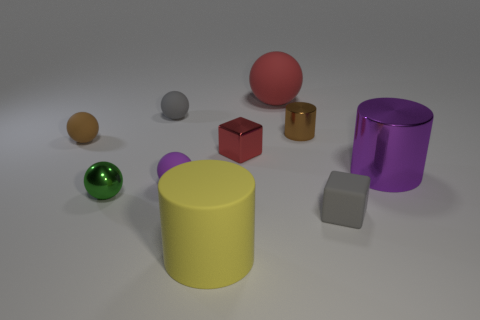Subtract 2 spheres. How many spheres are left? 3 Subtract all purple balls. How many balls are left? 4 Subtract all tiny brown rubber spheres. How many spheres are left? 4 Subtract all yellow balls. Subtract all brown blocks. How many balls are left? 5 Subtract all cubes. How many objects are left? 8 Add 9 tiny metallic blocks. How many tiny metallic blocks are left? 10 Add 8 yellow cylinders. How many yellow cylinders exist? 9 Subtract 0 yellow spheres. How many objects are left? 10 Subtract all tiny green metal cubes. Subtract all metal things. How many objects are left? 6 